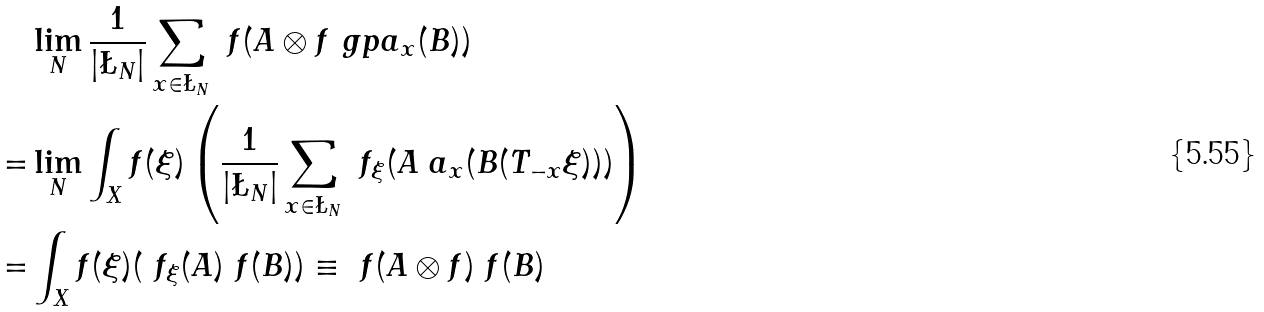<formula> <loc_0><loc_0><loc_500><loc_500>& \lim _ { N } \frac { 1 } { | \L _ { N } | } \sum _ { x \in \L _ { N } } \ f ( A \otimes f \ g p a _ { x } ( B ) ) \\ = & \lim _ { N } \int _ { X } f ( \xi ) \left ( \frac { 1 } { | \L _ { N } | } \sum _ { x \in \L _ { N } } \ f _ { \xi } ( A \ a _ { x } ( B ( T _ { - x } \xi ) ) ) \right ) \\ = & \int _ { X } f ( \xi ) ( \ f _ { \xi } ( A ) \ f ( B ) ) \equiv \ f ( A \otimes f ) \ f ( B )</formula> 